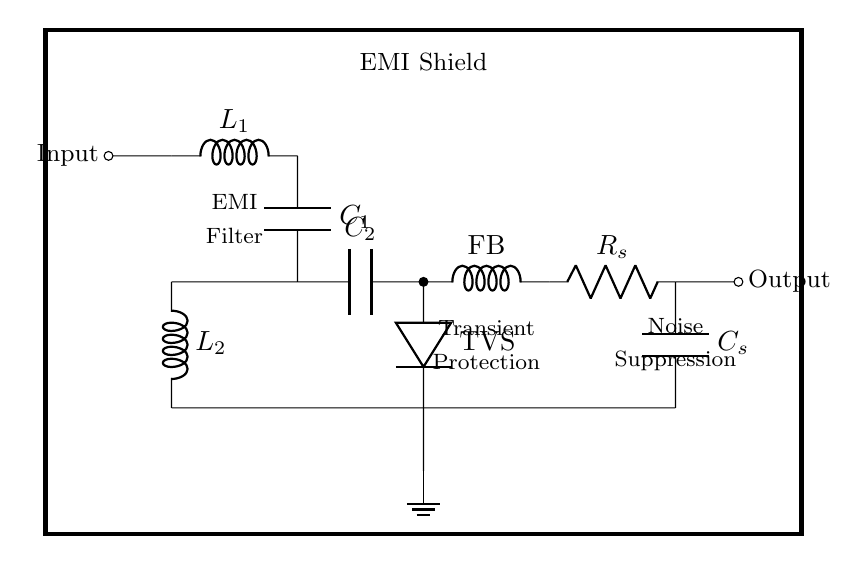What is the purpose of the EMI shield in this circuit? The EMI shield serves to protect sensitive communication devices from electromagnetic interference. It is designed to absorb and reflect EMI, preventing it from affecting the components within.
Answer: EMI protection What type of components are L1 and L2? L1 and L2 are inductors, which are used in the EMI filter to block high-frequency noise while allowing the desired signals to pass through. Their presence indicates a filtering function in the circuit.
Answer: Inductors What is the function of the TVS diode in the circuit? The TVS diode provides transient voltage suppression to protect sensitive components from voltage spikes or surges. It clamps excessive voltages, preventing damage to downstream devices.
Answer: Transient protection How many capacitors are present in the circuit? There are two capacitors labeled C1 and C2, providing additional noise filtering and stabilization in conjunction with the inductors.
Answer: Two Explain the role of the ferrite bead in the circuit. The ferrite bead is used for noise suppression, attenuating high-frequency noise and unwanted signals on the power or signal lines. It helps smooth out the signal passing through the circuit, enhancing overall performance.
Answer: Noise suppression What connections are made to ground in this circuit? The ground connections are made at point 5, and it is connected to the output of the EMI filter and other components, creating a common reference point for the circuit. This is crucial for safe operation and signal integrity.
Answer: At point 5 What does the R_s and C_s pair form in the circuit? R_s and C_s form an RC snubber, which is used for reducing voltage spikes and providing better stability during rapid changes in current, further protecting sensitive components from transients.
Answer: RC snubber 